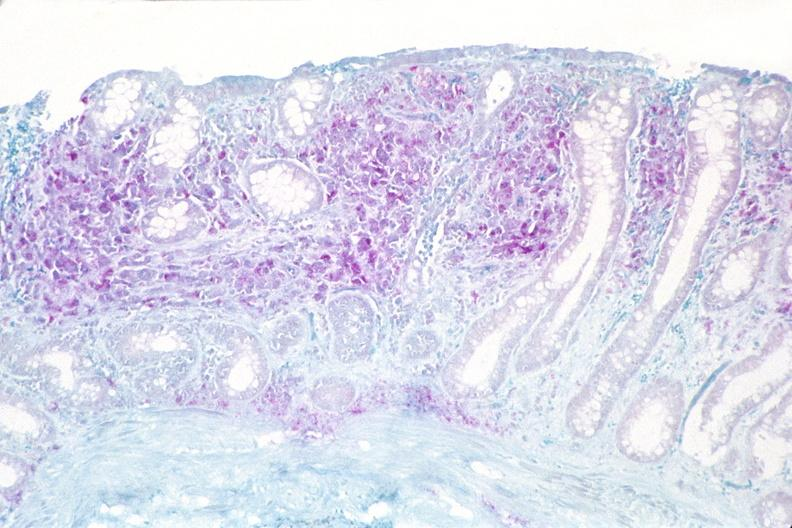does this image show colon biopsy, mycobacterium avium-intracellularae?
Answer the question using a single word or phrase. Yes 